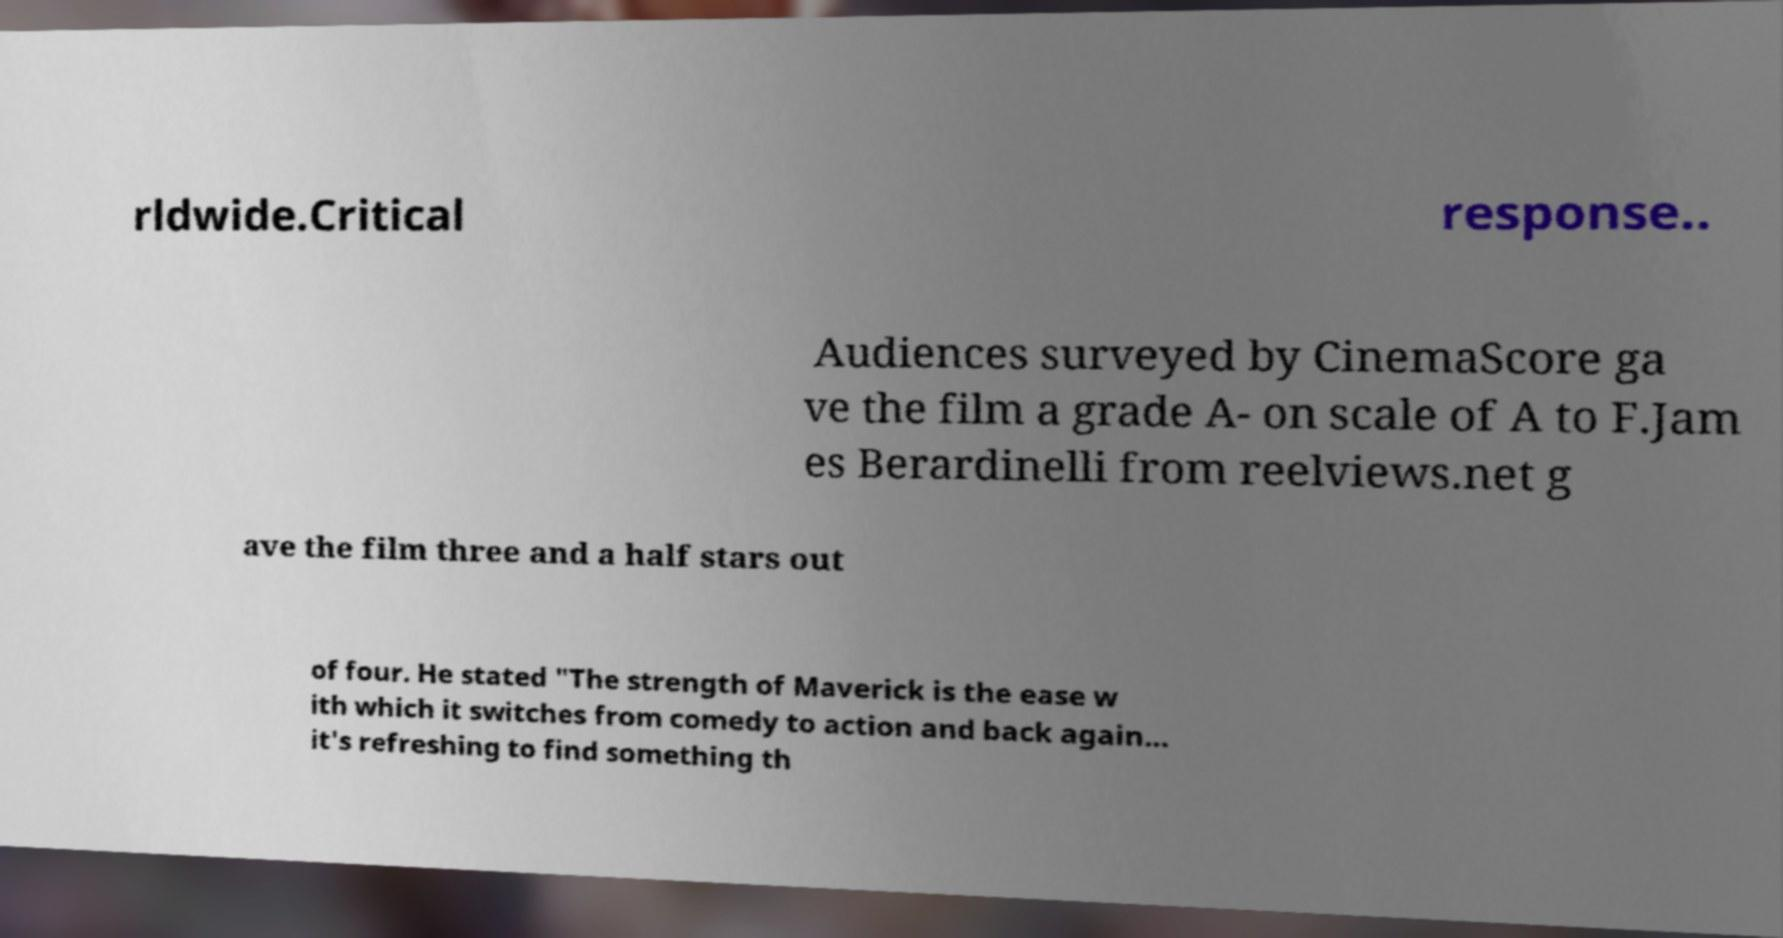What messages or text are displayed in this image? I need them in a readable, typed format. rldwide.Critical response.. Audiences surveyed by CinemaScore ga ve the film a grade A- on scale of A to F.Jam es Berardinelli from reelviews.net g ave the film three and a half stars out of four. He stated "The strength of Maverick is the ease w ith which it switches from comedy to action and back again... it's refreshing to find something th 